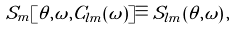Convert formula to latex. <formula><loc_0><loc_0><loc_500><loc_500>S _ { m } [ \theta , \omega , C _ { l m } ( \omega ) ] \equiv S _ { l m } ( \theta , \omega ) \, ,</formula> 